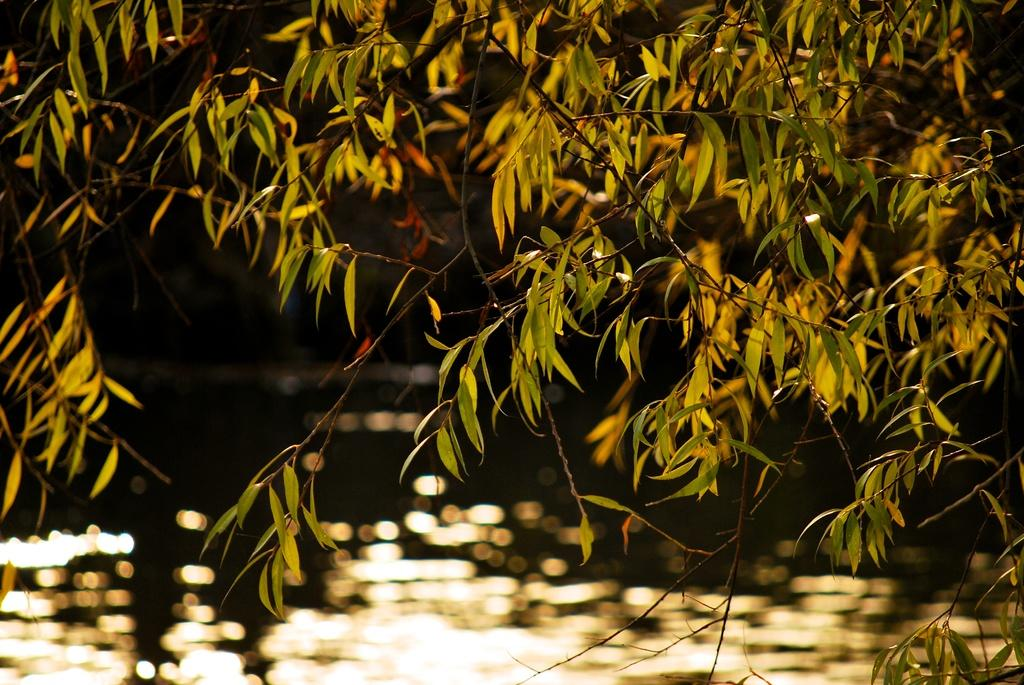What type of vegetation can be seen in the image? There are green leaves in the image. What natural element is visible in the image? There is water visible in the image. Can you tell me how many snails are crawling on the leaves in the image? There are no snails present in the image; it only features green leaves and water. 